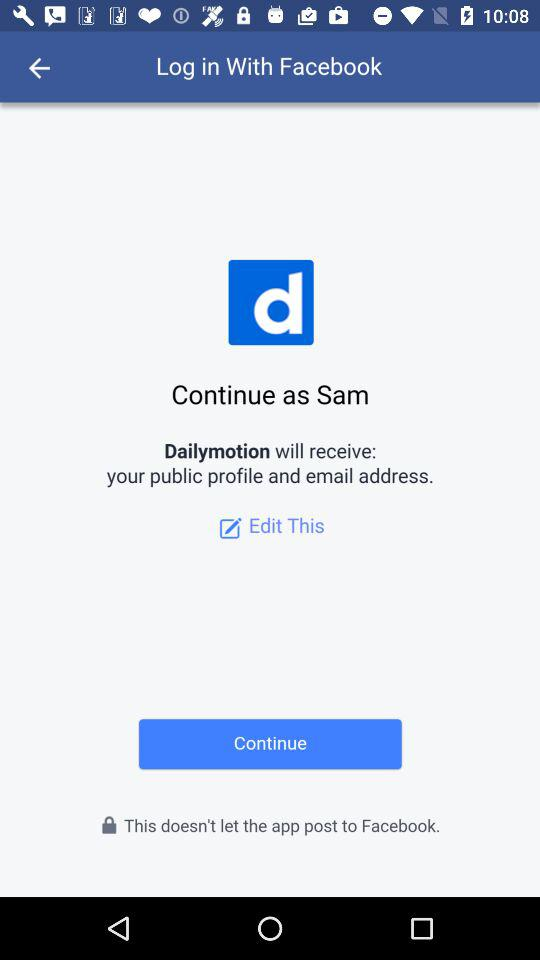What application is asking for access? The application asking for access is "Dailymotion". 